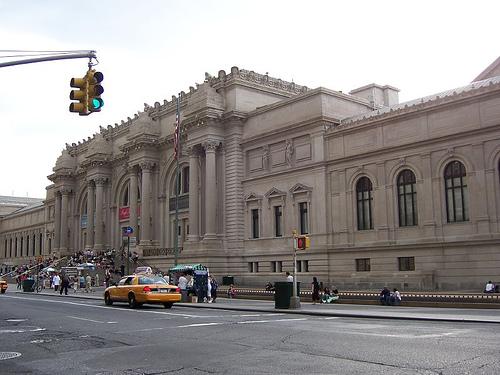What color is the taxi cab?
Concise answer only. Yellow. Is there traffic on the table?
Give a very brief answer. No. What color is the traffic light glowing?
Concise answer only. Green. 